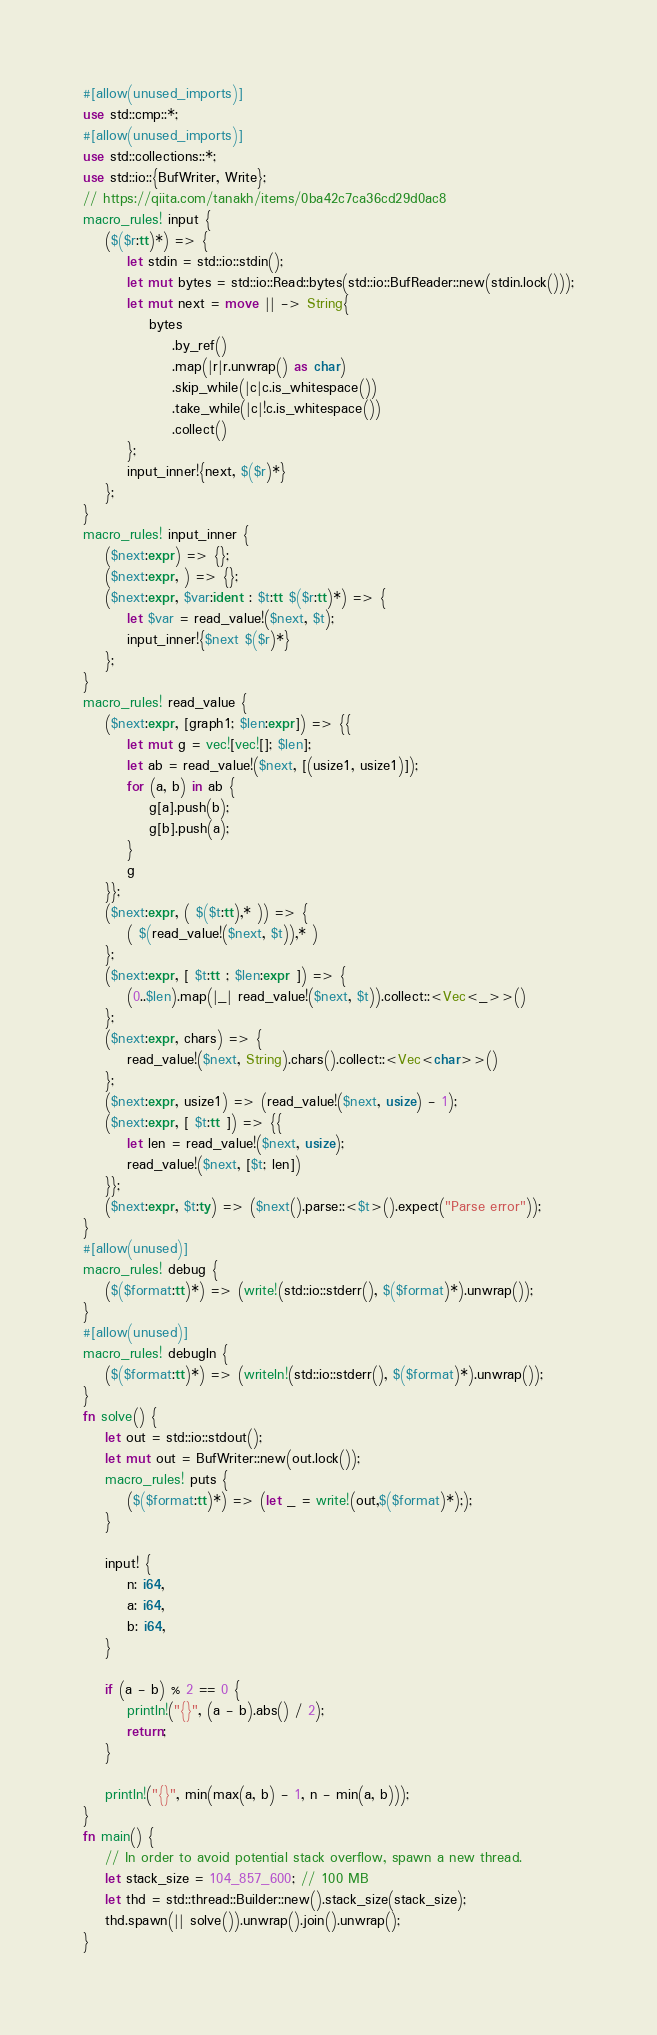Convert code to text. <code><loc_0><loc_0><loc_500><loc_500><_Rust_>#[allow(unused_imports)]
use std::cmp::*;
#[allow(unused_imports)]
use std::collections::*;
use std::io::{BufWriter, Write};
// https://qiita.com/tanakh/items/0ba42c7ca36cd29d0ac8
macro_rules! input {
    ($($r:tt)*) => {
        let stdin = std::io::stdin();
        let mut bytes = std::io::Read::bytes(std::io::BufReader::new(stdin.lock()));
        let mut next = move || -> String{
            bytes
                .by_ref()
                .map(|r|r.unwrap() as char)
                .skip_while(|c|c.is_whitespace())
                .take_while(|c|!c.is_whitespace())
                .collect()
        };
        input_inner!{next, $($r)*}
    };
}
macro_rules! input_inner {
    ($next:expr) => {};
    ($next:expr, ) => {};
    ($next:expr, $var:ident : $t:tt $($r:tt)*) => {
        let $var = read_value!($next, $t);
        input_inner!{$next $($r)*}
    };
}
macro_rules! read_value {
    ($next:expr, [graph1; $len:expr]) => {{
        let mut g = vec![vec![]; $len];
        let ab = read_value!($next, [(usize1, usize1)]);
        for (a, b) in ab {
            g[a].push(b);
            g[b].push(a);
        }
        g
    }};
    ($next:expr, ( $($t:tt),* )) => {
        ( $(read_value!($next, $t)),* )
    };
    ($next:expr, [ $t:tt ; $len:expr ]) => {
        (0..$len).map(|_| read_value!($next, $t)).collect::<Vec<_>>()
    };
    ($next:expr, chars) => {
        read_value!($next, String).chars().collect::<Vec<char>>()
    };
    ($next:expr, usize1) => (read_value!($next, usize) - 1);
    ($next:expr, [ $t:tt ]) => {{
        let len = read_value!($next, usize);
        read_value!($next, [$t; len])
    }};
    ($next:expr, $t:ty) => ($next().parse::<$t>().expect("Parse error"));
}
#[allow(unused)]
macro_rules! debug {
    ($($format:tt)*) => (write!(std::io::stderr(), $($format)*).unwrap());
}
#[allow(unused)]
macro_rules! debugln {
    ($($format:tt)*) => (writeln!(std::io::stderr(), $($format)*).unwrap());
}
fn solve() {
    let out = std::io::stdout();
    let mut out = BufWriter::new(out.lock());
    macro_rules! puts {
        ($($format:tt)*) => (let _ = write!(out,$($format)*););
    }

    input! {
        n: i64,
        a: i64,
        b: i64,
    }

    if (a - b) % 2 == 0 {
        println!("{}", (a - b).abs() / 2);
        return;
    }

    println!("{}", min(max(a, b) - 1, n - min(a, b)));
}
fn main() {
    // In order to avoid potential stack overflow, spawn a new thread.
    let stack_size = 104_857_600; // 100 MB
    let thd = std::thread::Builder::new().stack_size(stack_size);
    thd.spawn(|| solve()).unwrap().join().unwrap();
}
</code> 